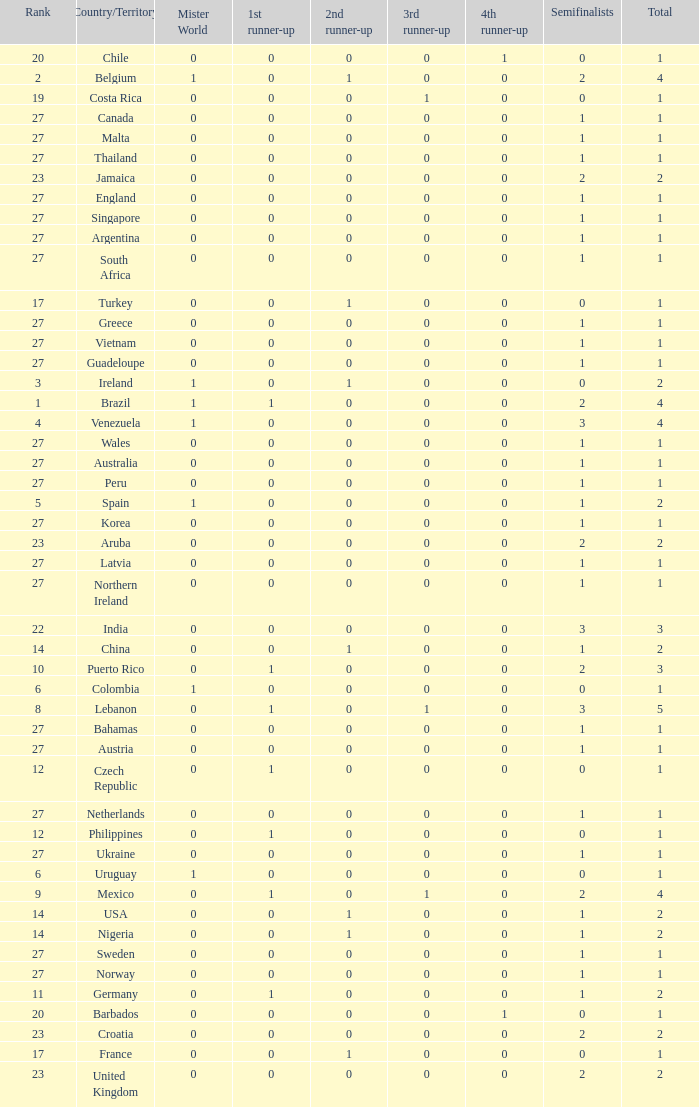What is the count of 1st runner-up positions held by jamaica? 1.0. 